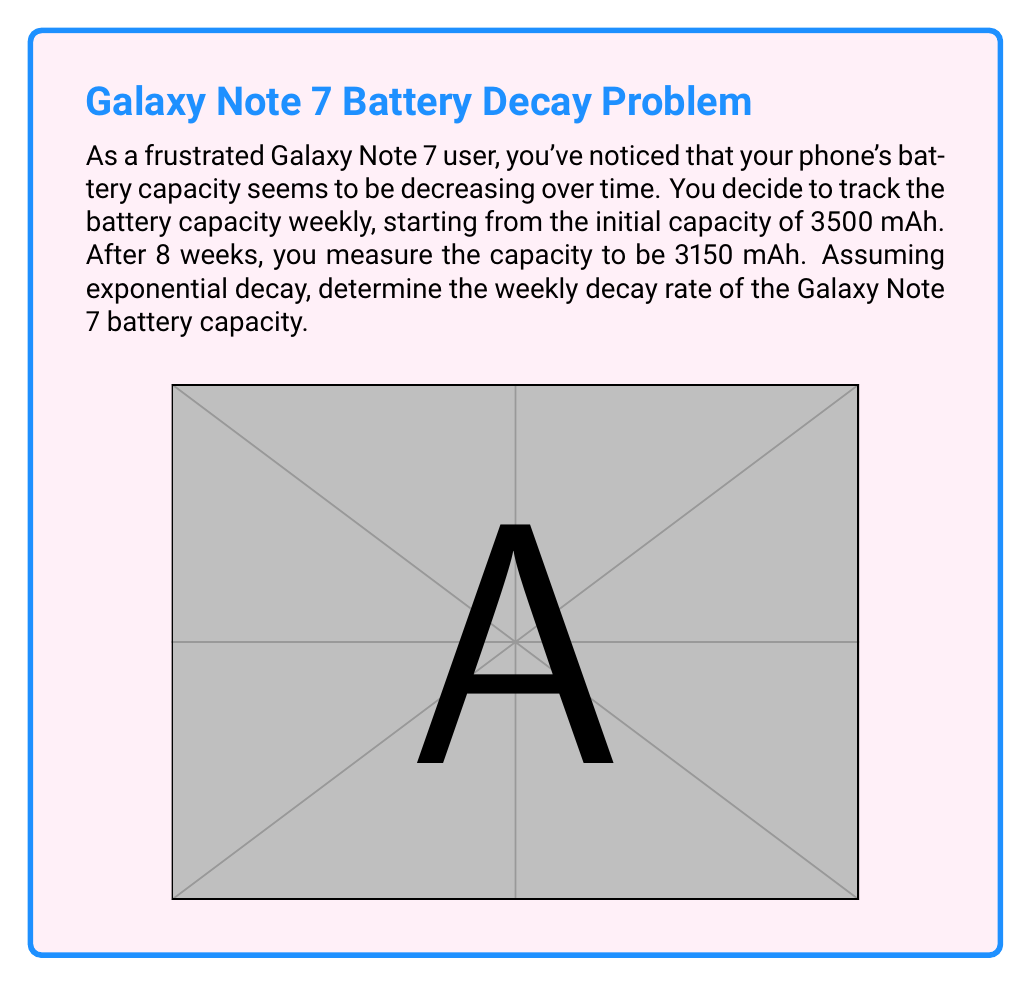Teach me how to tackle this problem. Let's approach this step-by-step using the exponential decay formula:

1) The general form of exponential decay is:
   $$A(t) = A_0 e^{-rt}$$
   where $A(t)$ is the amount at time $t$, $A_0$ is the initial amount, $r$ is the decay rate, and $t$ is time.

2) We know:
   $A_0 = 3500$ mAh (initial capacity)
   $A(8) = 3150$ mAh (capacity after 8 weeks)
   $t = 8$ weeks

3) Let's plug these into our formula:
   $$3150 = 3500 e^{-8r}$$

4) Divide both sides by 3500:
   $$\frac{3150}{3500} = e^{-8r}$$

5) Take the natural log of both sides:
   $$\ln(\frac{3150}{3500}) = -8r$$

6) Solve for $r$:
   $$r = -\frac{1}{8} \ln(\frac{3150}{3500})$$

7) Calculate:
   $$r = -\frac{1}{8} \ln(0.9) \approx 0.0137$$

Therefore, the weekly decay rate is approximately 0.0137 or 1.37% per week.
Answer: $r \approx 0.0137$ per week 